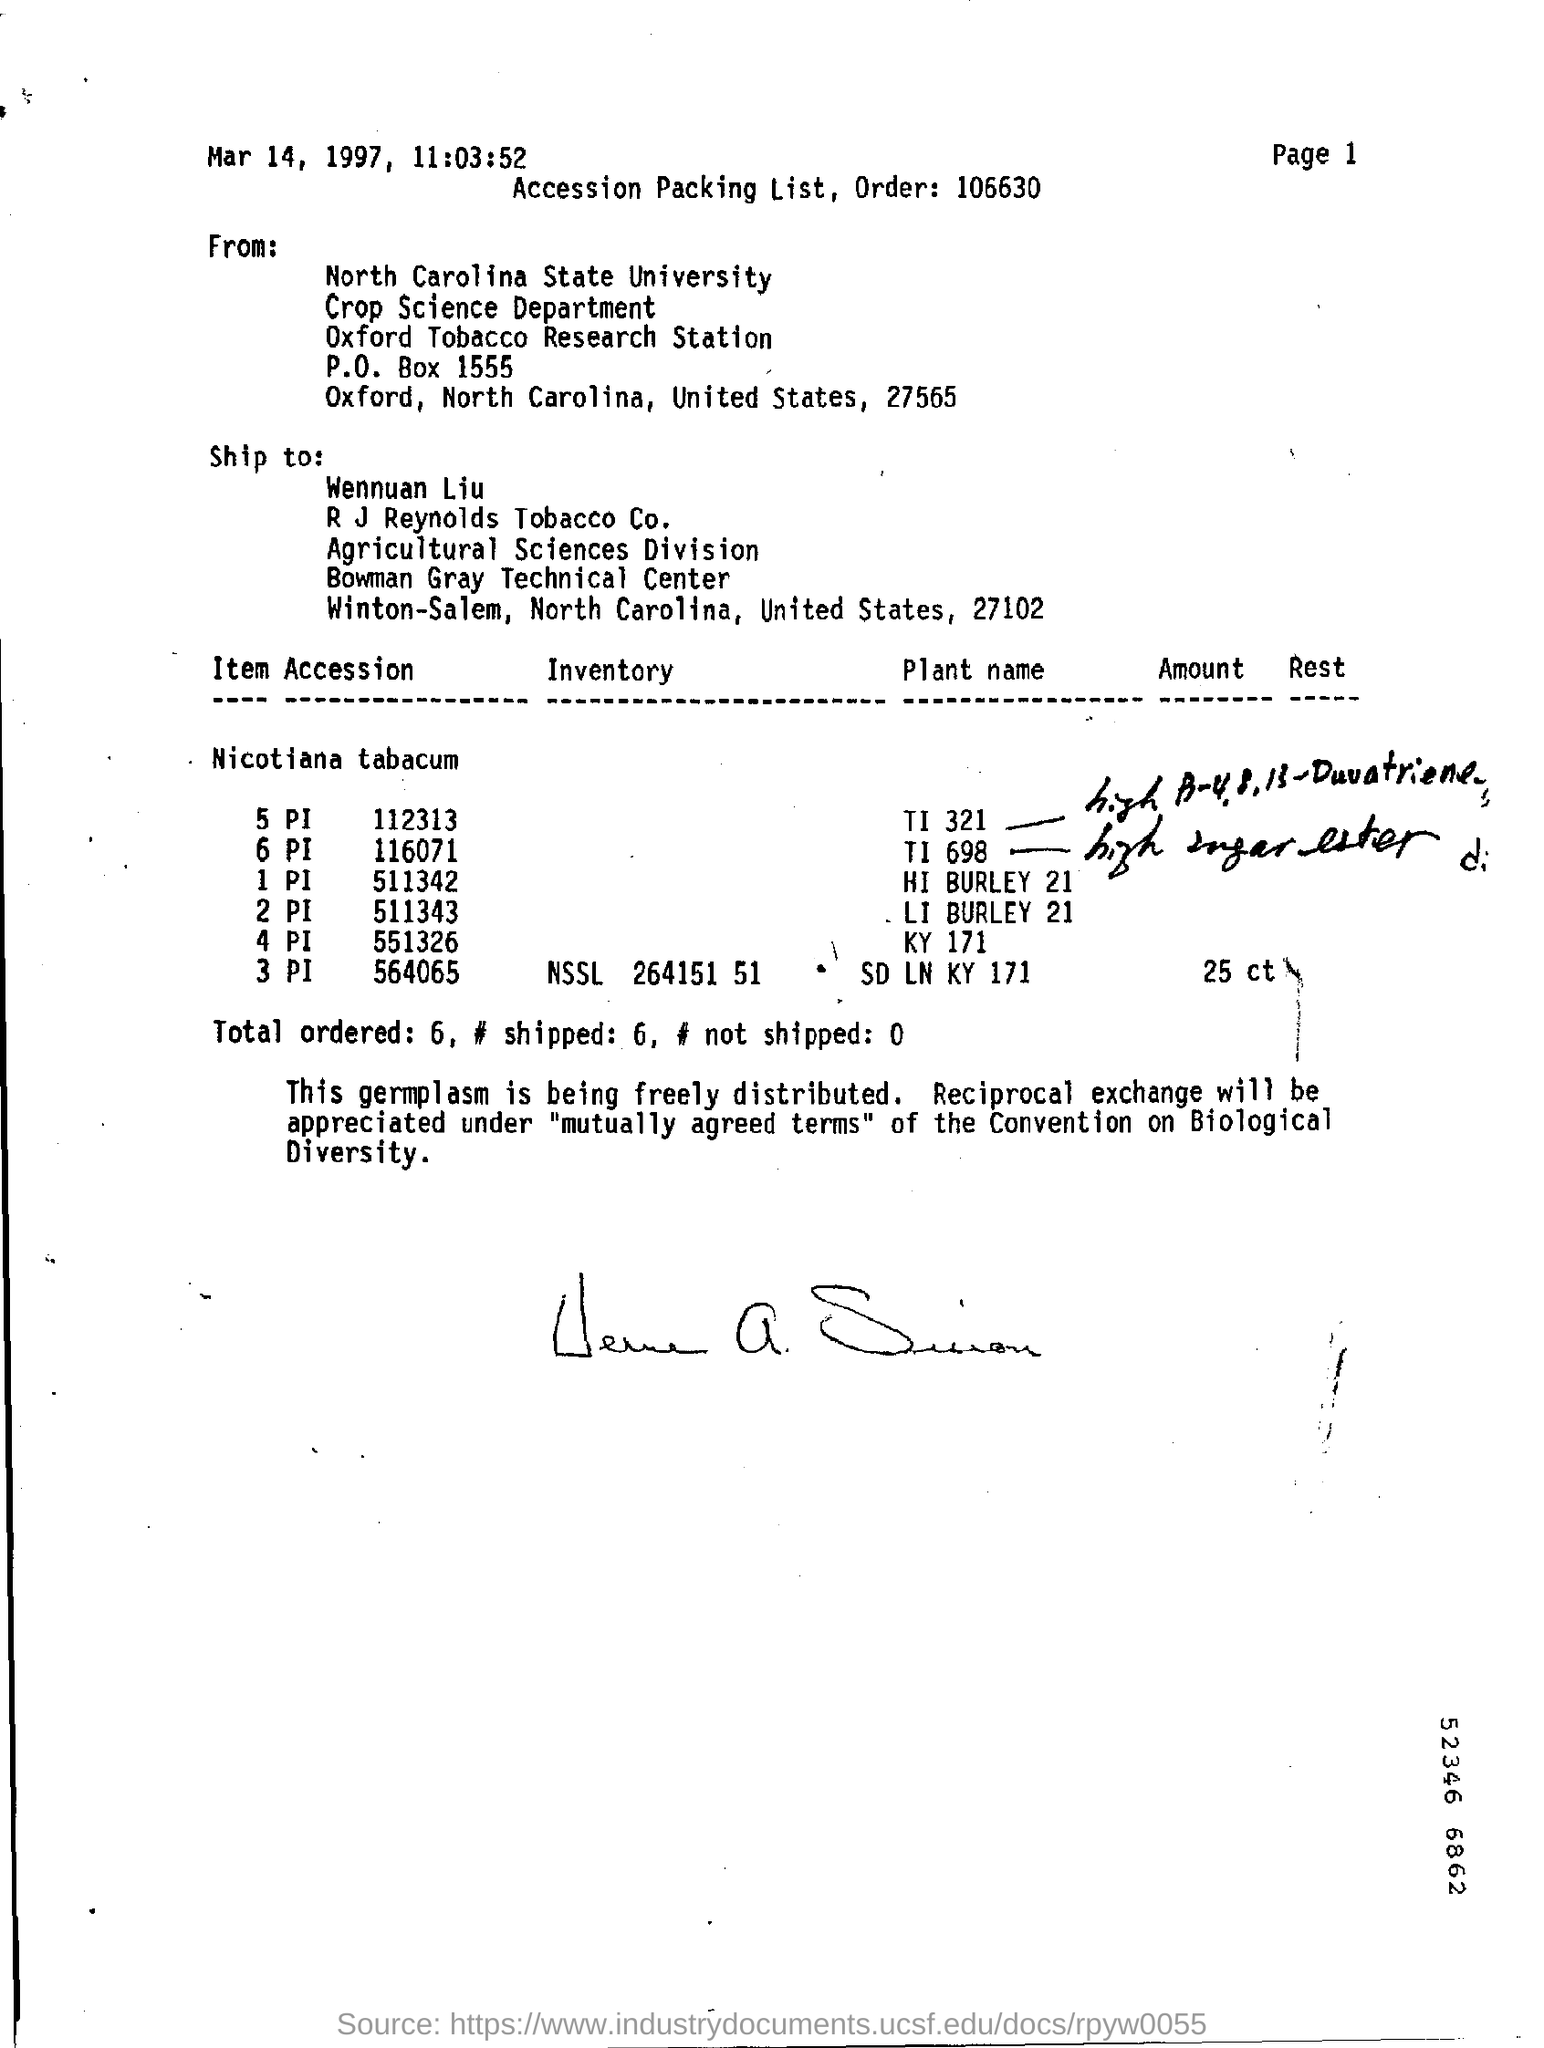Outline some significant characteristics in this image. The date mentioned is March 14, 1997. 6 units have been shipped. The time mentioned is 11:03:52. The North Carolina State University sent the message. This shipment is addressed to Wennuan Liu. 